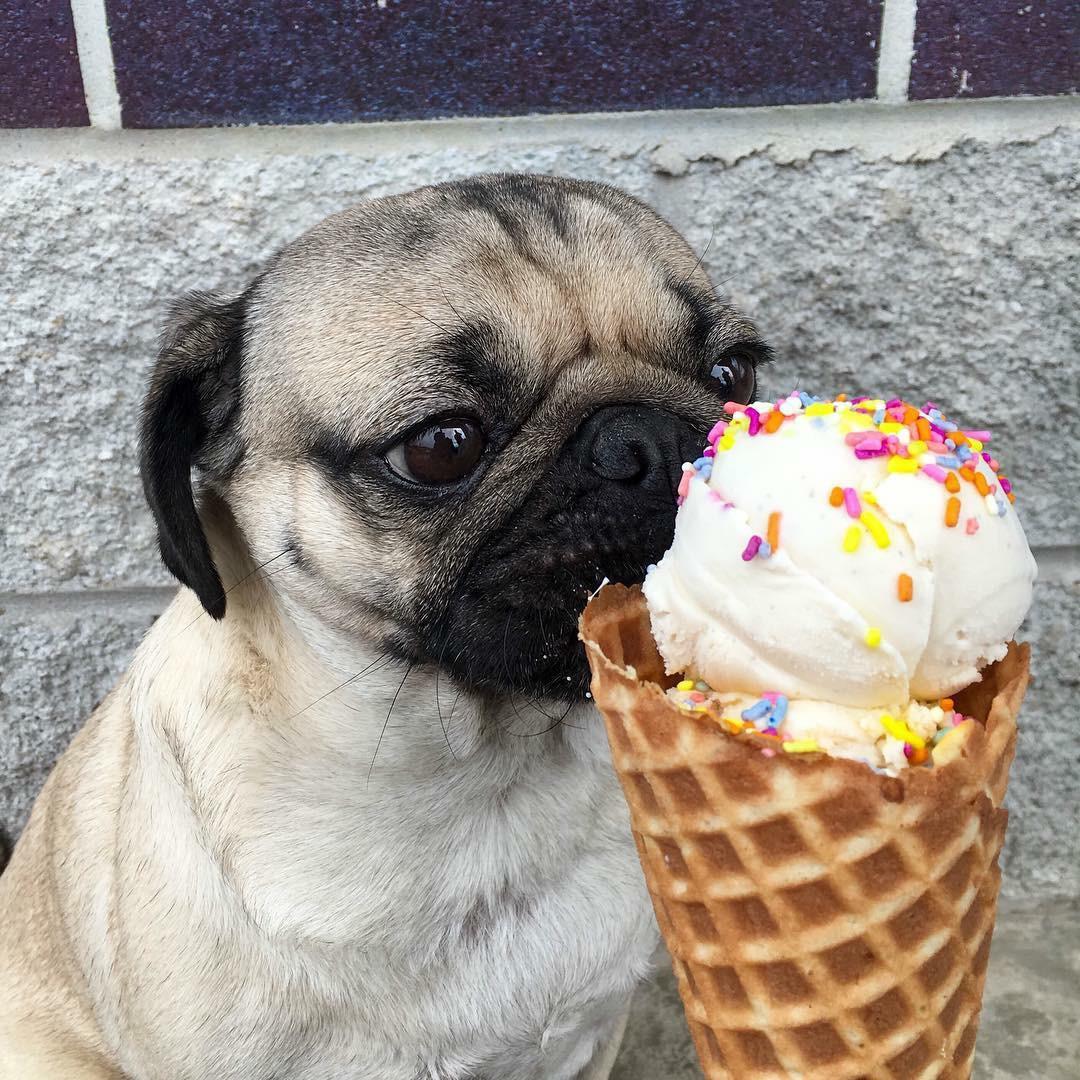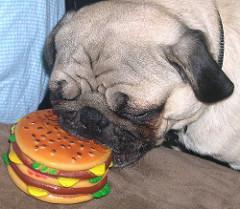The first image is the image on the left, the second image is the image on the right. Evaluate the accuracy of this statement regarding the images: "Atleast one picture contains a bowl with food.". Is it true? Answer yes or no. No. The first image is the image on the left, the second image is the image on the right. Considering the images on both sides, is "In the left image, a dog is eating some food set up for a human." valid? Answer yes or no. Yes. 